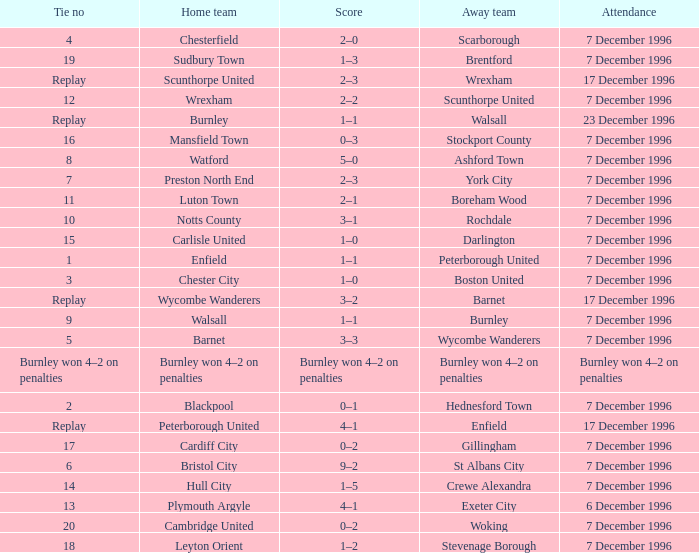What was the score of tie number 15? 1–0. 